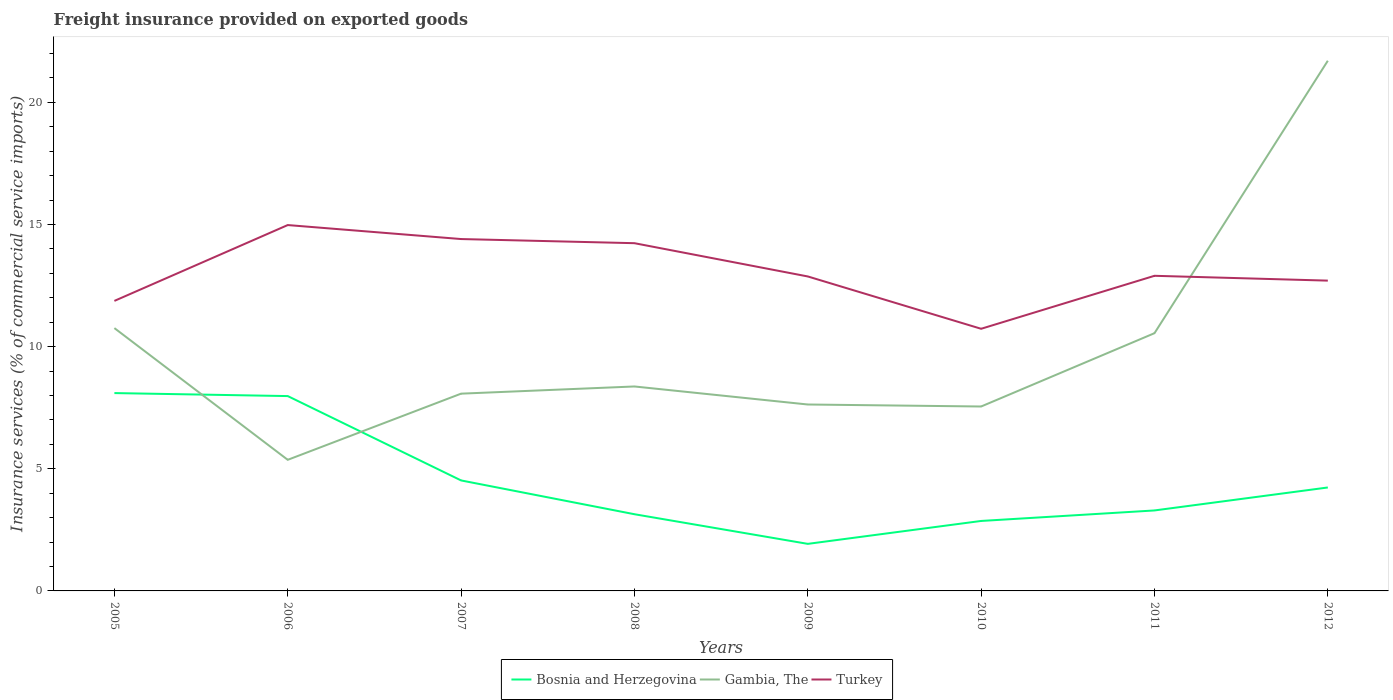How many different coloured lines are there?
Offer a very short reply. 3. Across all years, what is the maximum freight insurance provided on exported goods in Gambia, The?
Your answer should be compact. 5.37. What is the total freight insurance provided on exported goods in Bosnia and Herzegovina in the graph?
Ensure brevity in your answer.  1.66. What is the difference between the highest and the second highest freight insurance provided on exported goods in Gambia, The?
Ensure brevity in your answer.  16.34. Is the freight insurance provided on exported goods in Bosnia and Herzegovina strictly greater than the freight insurance provided on exported goods in Turkey over the years?
Ensure brevity in your answer.  Yes. How many lines are there?
Offer a terse response. 3. How many years are there in the graph?
Provide a succinct answer. 8. What is the difference between two consecutive major ticks on the Y-axis?
Ensure brevity in your answer.  5. Does the graph contain grids?
Your answer should be compact. No. Where does the legend appear in the graph?
Your answer should be very brief. Bottom center. How many legend labels are there?
Give a very brief answer. 3. What is the title of the graph?
Ensure brevity in your answer.  Freight insurance provided on exported goods. Does "Least developed countries" appear as one of the legend labels in the graph?
Give a very brief answer. No. What is the label or title of the Y-axis?
Give a very brief answer. Insurance services (% of commercial service imports). What is the Insurance services (% of commercial service imports) in Bosnia and Herzegovina in 2005?
Your response must be concise. 8.1. What is the Insurance services (% of commercial service imports) in Gambia, The in 2005?
Keep it short and to the point. 10.76. What is the Insurance services (% of commercial service imports) in Turkey in 2005?
Offer a terse response. 11.87. What is the Insurance services (% of commercial service imports) in Bosnia and Herzegovina in 2006?
Make the answer very short. 7.98. What is the Insurance services (% of commercial service imports) in Gambia, The in 2006?
Your answer should be very brief. 5.37. What is the Insurance services (% of commercial service imports) of Turkey in 2006?
Keep it short and to the point. 14.98. What is the Insurance services (% of commercial service imports) in Bosnia and Herzegovina in 2007?
Offer a terse response. 4.52. What is the Insurance services (% of commercial service imports) in Gambia, The in 2007?
Keep it short and to the point. 8.08. What is the Insurance services (% of commercial service imports) of Turkey in 2007?
Keep it short and to the point. 14.4. What is the Insurance services (% of commercial service imports) of Bosnia and Herzegovina in 2008?
Provide a short and direct response. 3.14. What is the Insurance services (% of commercial service imports) in Gambia, The in 2008?
Offer a very short reply. 8.37. What is the Insurance services (% of commercial service imports) in Turkey in 2008?
Offer a very short reply. 14.23. What is the Insurance services (% of commercial service imports) in Bosnia and Herzegovina in 2009?
Your answer should be compact. 1.93. What is the Insurance services (% of commercial service imports) in Gambia, The in 2009?
Offer a very short reply. 7.63. What is the Insurance services (% of commercial service imports) in Turkey in 2009?
Your answer should be compact. 12.87. What is the Insurance services (% of commercial service imports) in Bosnia and Herzegovina in 2010?
Your response must be concise. 2.86. What is the Insurance services (% of commercial service imports) in Gambia, The in 2010?
Your answer should be very brief. 7.55. What is the Insurance services (% of commercial service imports) in Turkey in 2010?
Your answer should be very brief. 10.73. What is the Insurance services (% of commercial service imports) of Bosnia and Herzegovina in 2011?
Your answer should be compact. 3.29. What is the Insurance services (% of commercial service imports) in Gambia, The in 2011?
Offer a very short reply. 10.55. What is the Insurance services (% of commercial service imports) of Turkey in 2011?
Your answer should be compact. 12.9. What is the Insurance services (% of commercial service imports) in Bosnia and Herzegovina in 2012?
Keep it short and to the point. 4.23. What is the Insurance services (% of commercial service imports) in Gambia, The in 2012?
Give a very brief answer. 21.7. What is the Insurance services (% of commercial service imports) of Turkey in 2012?
Give a very brief answer. 12.7. Across all years, what is the maximum Insurance services (% of commercial service imports) of Bosnia and Herzegovina?
Give a very brief answer. 8.1. Across all years, what is the maximum Insurance services (% of commercial service imports) of Gambia, The?
Provide a succinct answer. 21.7. Across all years, what is the maximum Insurance services (% of commercial service imports) of Turkey?
Offer a very short reply. 14.98. Across all years, what is the minimum Insurance services (% of commercial service imports) in Bosnia and Herzegovina?
Provide a short and direct response. 1.93. Across all years, what is the minimum Insurance services (% of commercial service imports) of Gambia, The?
Ensure brevity in your answer.  5.37. Across all years, what is the minimum Insurance services (% of commercial service imports) of Turkey?
Offer a terse response. 10.73. What is the total Insurance services (% of commercial service imports) of Bosnia and Herzegovina in the graph?
Offer a terse response. 36.06. What is the total Insurance services (% of commercial service imports) in Gambia, The in the graph?
Offer a very short reply. 80.01. What is the total Insurance services (% of commercial service imports) in Turkey in the graph?
Keep it short and to the point. 104.69. What is the difference between the Insurance services (% of commercial service imports) in Bosnia and Herzegovina in 2005 and that in 2006?
Your answer should be very brief. 0.12. What is the difference between the Insurance services (% of commercial service imports) in Gambia, The in 2005 and that in 2006?
Give a very brief answer. 5.39. What is the difference between the Insurance services (% of commercial service imports) of Turkey in 2005 and that in 2006?
Your answer should be compact. -3.1. What is the difference between the Insurance services (% of commercial service imports) in Bosnia and Herzegovina in 2005 and that in 2007?
Provide a succinct answer. 3.58. What is the difference between the Insurance services (% of commercial service imports) in Gambia, The in 2005 and that in 2007?
Ensure brevity in your answer.  2.68. What is the difference between the Insurance services (% of commercial service imports) of Turkey in 2005 and that in 2007?
Make the answer very short. -2.53. What is the difference between the Insurance services (% of commercial service imports) of Bosnia and Herzegovina in 2005 and that in 2008?
Give a very brief answer. 4.96. What is the difference between the Insurance services (% of commercial service imports) of Gambia, The in 2005 and that in 2008?
Provide a short and direct response. 2.39. What is the difference between the Insurance services (% of commercial service imports) in Turkey in 2005 and that in 2008?
Give a very brief answer. -2.36. What is the difference between the Insurance services (% of commercial service imports) in Bosnia and Herzegovina in 2005 and that in 2009?
Give a very brief answer. 6.17. What is the difference between the Insurance services (% of commercial service imports) of Gambia, The in 2005 and that in 2009?
Your response must be concise. 3.13. What is the difference between the Insurance services (% of commercial service imports) of Turkey in 2005 and that in 2009?
Offer a terse response. -1. What is the difference between the Insurance services (% of commercial service imports) in Bosnia and Herzegovina in 2005 and that in 2010?
Make the answer very short. 5.23. What is the difference between the Insurance services (% of commercial service imports) in Gambia, The in 2005 and that in 2010?
Offer a terse response. 3.21. What is the difference between the Insurance services (% of commercial service imports) of Turkey in 2005 and that in 2010?
Your answer should be compact. 1.14. What is the difference between the Insurance services (% of commercial service imports) in Bosnia and Herzegovina in 2005 and that in 2011?
Keep it short and to the point. 4.8. What is the difference between the Insurance services (% of commercial service imports) of Gambia, The in 2005 and that in 2011?
Your answer should be very brief. 0.21. What is the difference between the Insurance services (% of commercial service imports) in Turkey in 2005 and that in 2011?
Ensure brevity in your answer.  -1.03. What is the difference between the Insurance services (% of commercial service imports) of Bosnia and Herzegovina in 2005 and that in 2012?
Make the answer very short. 3.86. What is the difference between the Insurance services (% of commercial service imports) of Gambia, The in 2005 and that in 2012?
Keep it short and to the point. -10.94. What is the difference between the Insurance services (% of commercial service imports) in Turkey in 2005 and that in 2012?
Provide a succinct answer. -0.83. What is the difference between the Insurance services (% of commercial service imports) in Bosnia and Herzegovina in 2006 and that in 2007?
Make the answer very short. 3.45. What is the difference between the Insurance services (% of commercial service imports) of Gambia, The in 2006 and that in 2007?
Your answer should be compact. -2.71. What is the difference between the Insurance services (% of commercial service imports) of Turkey in 2006 and that in 2007?
Your answer should be very brief. 0.57. What is the difference between the Insurance services (% of commercial service imports) in Bosnia and Herzegovina in 2006 and that in 2008?
Give a very brief answer. 4.84. What is the difference between the Insurance services (% of commercial service imports) in Gambia, The in 2006 and that in 2008?
Your answer should be very brief. -3. What is the difference between the Insurance services (% of commercial service imports) of Turkey in 2006 and that in 2008?
Provide a succinct answer. 0.74. What is the difference between the Insurance services (% of commercial service imports) of Bosnia and Herzegovina in 2006 and that in 2009?
Provide a short and direct response. 6.05. What is the difference between the Insurance services (% of commercial service imports) in Gambia, The in 2006 and that in 2009?
Keep it short and to the point. -2.26. What is the difference between the Insurance services (% of commercial service imports) of Turkey in 2006 and that in 2009?
Provide a succinct answer. 2.1. What is the difference between the Insurance services (% of commercial service imports) in Bosnia and Herzegovina in 2006 and that in 2010?
Ensure brevity in your answer.  5.11. What is the difference between the Insurance services (% of commercial service imports) in Gambia, The in 2006 and that in 2010?
Provide a short and direct response. -2.18. What is the difference between the Insurance services (% of commercial service imports) in Turkey in 2006 and that in 2010?
Your response must be concise. 4.25. What is the difference between the Insurance services (% of commercial service imports) in Bosnia and Herzegovina in 2006 and that in 2011?
Offer a terse response. 4.68. What is the difference between the Insurance services (% of commercial service imports) of Gambia, The in 2006 and that in 2011?
Ensure brevity in your answer.  -5.18. What is the difference between the Insurance services (% of commercial service imports) in Turkey in 2006 and that in 2011?
Give a very brief answer. 2.08. What is the difference between the Insurance services (% of commercial service imports) in Bosnia and Herzegovina in 2006 and that in 2012?
Offer a very short reply. 3.74. What is the difference between the Insurance services (% of commercial service imports) of Gambia, The in 2006 and that in 2012?
Ensure brevity in your answer.  -16.34. What is the difference between the Insurance services (% of commercial service imports) in Turkey in 2006 and that in 2012?
Your answer should be very brief. 2.27. What is the difference between the Insurance services (% of commercial service imports) in Bosnia and Herzegovina in 2007 and that in 2008?
Your answer should be very brief. 1.38. What is the difference between the Insurance services (% of commercial service imports) of Gambia, The in 2007 and that in 2008?
Your answer should be very brief. -0.29. What is the difference between the Insurance services (% of commercial service imports) in Turkey in 2007 and that in 2008?
Your answer should be very brief. 0.17. What is the difference between the Insurance services (% of commercial service imports) of Bosnia and Herzegovina in 2007 and that in 2009?
Ensure brevity in your answer.  2.6. What is the difference between the Insurance services (% of commercial service imports) in Gambia, The in 2007 and that in 2009?
Your response must be concise. 0.44. What is the difference between the Insurance services (% of commercial service imports) in Turkey in 2007 and that in 2009?
Provide a succinct answer. 1.53. What is the difference between the Insurance services (% of commercial service imports) of Bosnia and Herzegovina in 2007 and that in 2010?
Your answer should be very brief. 1.66. What is the difference between the Insurance services (% of commercial service imports) of Gambia, The in 2007 and that in 2010?
Give a very brief answer. 0.53. What is the difference between the Insurance services (% of commercial service imports) of Turkey in 2007 and that in 2010?
Give a very brief answer. 3.67. What is the difference between the Insurance services (% of commercial service imports) in Bosnia and Herzegovina in 2007 and that in 2011?
Provide a short and direct response. 1.23. What is the difference between the Insurance services (% of commercial service imports) of Gambia, The in 2007 and that in 2011?
Keep it short and to the point. -2.48. What is the difference between the Insurance services (% of commercial service imports) in Turkey in 2007 and that in 2011?
Offer a terse response. 1.5. What is the difference between the Insurance services (% of commercial service imports) in Bosnia and Herzegovina in 2007 and that in 2012?
Your response must be concise. 0.29. What is the difference between the Insurance services (% of commercial service imports) of Gambia, The in 2007 and that in 2012?
Your answer should be compact. -13.63. What is the difference between the Insurance services (% of commercial service imports) in Turkey in 2007 and that in 2012?
Ensure brevity in your answer.  1.7. What is the difference between the Insurance services (% of commercial service imports) of Bosnia and Herzegovina in 2008 and that in 2009?
Provide a succinct answer. 1.21. What is the difference between the Insurance services (% of commercial service imports) of Gambia, The in 2008 and that in 2009?
Offer a terse response. 0.74. What is the difference between the Insurance services (% of commercial service imports) of Turkey in 2008 and that in 2009?
Ensure brevity in your answer.  1.36. What is the difference between the Insurance services (% of commercial service imports) of Bosnia and Herzegovina in 2008 and that in 2010?
Ensure brevity in your answer.  0.28. What is the difference between the Insurance services (% of commercial service imports) in Gambia, The in 2008 and that in 2010?
Ensure brevity in your answer.  0.82. What is the difference between the Insurance services (% of commercial service imports) in Turkey in 2008 and that in 2010?
Offer a very short reply. 3.5. What is the difference between the Insurance services (% of commercial service imports) in Bosnia and Herzegovina in 2008 and that in 2011?
Give a very brief answer. -0.15. What is the difference between the Insurance services (% of commercial service imports) in Gambia, The in 2008 and that in 2011?
Offer a terse response. -2.18. What is the difference between the Insurance services (% of commercial service imports) of Turkey in 2008 and that in 2011?
Provide a succinct answer. 1.33. What is the difference between the Insurance services (% of commercial service imports) in Bosnia and Herzegovina in 2008 and that in 2012?
Provide a succinct answer. -1.09. What is the difference between the Insurance services (% of commercial service imports) in Gambia, The in 2008 and that in 2012?
Offer a terse response. -13.33. What is the difference between the Insurance services (% of commercial service imports) in Turkey in 2008 and that in 2012?
Keep it short and to the point. 1.53. What is the difference between the Insurance services (% of commercial service imports) of Bosnia and Herzegovina in 2009 and that in 2010?
Your response must be concise. -0.94. What is the difference between the Insurance services (% of commercial service imports) of Gambia, The in 2009 and that in 2010?
Provide a succinct answer. 0.08. What is the difference between the Insurance services (% of commercial service imports) in Turkey in 2009 and that in 2010?
Keep it short and to the point. 2.14. What is the difference between the Insurance services (% of commercial service imports) in Bosnia and Herzegovina in 2009 and that in 2011?
Make the answer very short. -1.37. What is the difference between the Insurance services (% of commercial service imports) of Gambia, The in 2009 and that in 2011?
Your answer should be compact. -2.92. What is the difference between the Insurance services (% of commercial service imports) in Turkey in 2009 and that in 2011?
Provide a short and direct response. -0.03. What is the difference between the Insurance services (% of commercial service imports) in Bosnia and Herzegovina in 2009 and that in 2012?
Provide a short and direct response. -2.31. What is the difference between the Insurance services (% of commercial service imports) in Gambia, The in 2009 and that in 2012?
Keep it short and to the point. -14.07. What is the difference between the Insurance services (% of commercial service imports) in Turkey in 2009 and that in 2012?
Your response must be concise. 0.17. What is the difference between the Insurance services (% of commercial service imports) of Bosnia and Herzegovina in 2010 and that in 2011?
Your response must be concise. -0.43. What is the difference between the Insurance services (% of commercial service imports) in Gambia, The in 2010 and that in 2011?
Give a very brief answer. -3. What is the difference between the Insurance services (% of commercial service imports) of Turkey in 2010 and that in 2011?
Give a very brief answer. -2.17. What is the difference between the Insurance services (% of commercial service imports) in Bosnia and Herzegovina in 2010 and that in 2012?
Ensure brevity in your answer.  -1.37. What is the difference between the Insurance services (% of commercial service imports) of Gambia, The in 2010 and that in 2012?
Offer a terse response. -14.15. What is the difference between the Insurance services (% of commercial service imports) of Turkey in 2010 and that in 2012?
Your response must be concise. -1.97. What is the difference between the Insurance services (% of commercial service imports) of Bosnia and Herzegovina in 2011 and that in 2012?
Make the answer very short. -0.94. What is the difference between the Insurance services (% of commercial service imports) of Gambia, The in 2011 and that in 2012?
Make the answer very short. -11.15. What is the difference between the Insurance services (% of commercial service imports) of Turkey in 2011 and that in 2012?
Make the answer very short. 0.2. What is the difference between the Insurance services (% of commercial service imports) in Bosnia and Herzegovina in 2005 and the Insurance services (% of commercial service imports) in Gambia, The in 2006?
Ensure brevity in your answer.  2.73. What is the difference between the Insurance services (% of commercial service imports) of Bosnia and Herzegovina in 2005 and the Insurance services (% of commercial service imports) of Turkey in 2006?
Ensure brevity in your answer.  -6.88. What is the difference between the Insurance services (% of commercial service imports) of Gambia, The in 2005 and the Insurance services (% of commercial service imports) of Turkey in 2006?
Ensure brevity in your answer.  -4.22. What is the difference between the Insurance services (% of commercial service imports) of Bosnia and Herzegovina in 2005 and the Insurance services (% of commercial service imports) of Gambia, The in 2007?
Offer a terse response. 0.02. What is the difference between the Insurance services (% of commercial service imports) in Bosnia and Herzegovina in 2005 and the Insurance services (% of commercial service imports) in Turkey in 2007?
Provide a short and direct response. -6.31. What is the difference between the Insurance services (% of commercial service imports) in Gambia, The in 2005 and the Insurance services (% of commercial service imports) in Turkey in 2007?
Offer a terse response. -3.65. What is the difference between the Insurance services (% of commercial service imports) of Bosnia and Herzegovina in 2005 and the Insurance services (% of commercial service imports) of Gambia, The in 2008?
Provide a short and direct response. -0.27. What is the difference between the Insurance services (% of commercial service imports) of Bosnia and Herzegovina in 2005 and the Insurance services (% of commercial service imports) of Turkey in 2008?
Offer a terse response. -6.14. What is the difference between the Insurance services (% of commercial service imports) in Gambia, The in 2005 and the Insurance services (% of commercial service imports) in Turkey in 2008?
Make the answer very short. -3.48. What is the difference between the Insurance services (% of commercial service imports) in Bosnia and Herzegovina in 2005 and the Insurance services (% of commercial service imports) in Gambia, The in 2009?
Provide a short and direct response. 0.47. What is the difference between the Insurance services (% of commercial service imports) in Bosnia and Herzegovina in 2005 and the Insurance services (% of commercial service imports) in Turkey in 2009?
Give a very brief answer. -4.77. What is the difference between the Insurance services (% of commercial service imports) in Gambia, The in 2005 and the Insurance services (% of commercial service imports) in Turkey in 2009?
Offer a terse response. -2.11. What is the difference between the Insurance services (% of commercial service imports) of Bosnia and Herzegovina in 2005 and the Insurance services (% of commercial service imports) of Gambia, The in 2010?
Make the answer very short. 0.55. What is the difference between the Insurance services (% of commercial service imports) of Bosnia and Herzegovina in 2005 and the Insurance services (% of commercial service imports) of Turkey in 2010?
Make the answer very short. -2.63. What is the difference between the Insurance services (% of commercial service imports) of Gambia, The in 2005 and the Insurance services (% of commercial service imports) of Turkey in 2010?
Keep it short and to the point. 0.03. What is the difference between the Insurance services (% of commercial service imports) in Bosnia and Herzegovina in 2005 and the Insurance services (% of commercial service imports) in Gambia, The in 2011?
Ensure brevity in your answer.  -2.45. What is the difference between the Insurance services (% of commercial service imports) of Bosnia and Herzegovina in 2005 and the Insurance services (% of commercial service imports) of Turkey in 2011?
Provide a succinct answer. -4.8. What is the difference between the Insurance services (% of commercial service imports) of Gambia, The in 2005 and the Insurance services (% of commercial service imports) of Turkey in 2011?
Offer a terse response. -2.14. What is the difference between the Insurance services (% of commercial service imports) in Bosnia and Herzegovina in 2005 and the Insurance services (% of commercial service imports) in Gambia, The in 2012?
Give a very brief answer. -13.61. What is the difference between the Insurance services (% of commercial service imports) in Bosnia and Herzegovina in 2005 and the Insurance services (% of commercial service imports) in Turkey in 2012?
Offer a very short reply. -4.6. What is the difference between the Insurance services (% of commercial service imports) of Gambia, The in 2005 and the Insurance services (% of commercial service imports) of Turkey in 2012?
Keep it short and to the point. -1.94. What is the difference between the Insurance services (% of commercial service imports) of Bosnia and Herzegovina in 2006 and the Insurance services (% of commercial service imports) of Gambia, The in 2007?
Provide a succinct answer. -0.1. What is the difference between the Insurance services (% of commercial service imports) in Bosnia and Herzegovina in 2006 and the Insurance services (% of commercial service imports) in Turkey in 2007?
Offer a very short reply. -6.43. What is the difference between the Insurance services (% of commercial service imports) in Gambia, The in 2006 and the Insurance services (% of commercial service imports) in Turkey in 2007?
Give a very brief answer. -9.04. What is the difference between the Insurance services (% of commercial service imports) of Bosnia and Herzegovina in 2006 and the Insurance services (% of commercial service imports) of Gambia, The in 2008?
Your answer should be very brief. -0.39. What is the difference between the Insurance services (% of commercial service imports) in Bosnia and Herzegovina in 2006 and the Insurance services (% of commercial service imports) in Turkey in 2008?
Offer a very short reply. -6.26. What is the difference between the Insurance services (% of commercial service imports) of Gambia, The in 2006 and the Insurance services (% of commercial service imports) of Turkey in 2008?
Keep it short and to the point. -8.87. What is the difference between the Insurance services (% of commercial service imports) of Bosnia and Herzegovina in 2006 and the Insurance services (% of commercial service imports) of Gambia, The in 2009?
Provide a short and direct response. 0.34. What is the difference between the Insurance services (% of commercial service imports) of Bosnia and Herzegovina in 2006 and the Insurance services (% of commercial service imports) of Turkey in 2009?
Your response must be concise. -4.9. What is the difference between the Insurance services (% of commercial service imports) in Gambia, The in 2006 and the Insurance services (% of commercial service imports) in Turkey in 2009?
Offer a terse response. -7.51. What is the difference between the Insurance services (% of commercial service imports) of Bosnia and Herzegovina in 2006 and the Insurance services (% of commercial service imports) of Gambia, The in 2010?
Give a very brief answer. 0.43. What is the difference between the Insurance services (% of commercial service imports) of Bosnia and Herzegovina in 2006 and the Insurance services (% of commercial service imports) of Turkey in 2010?
Offer a terse response. -2.75. What is the difference between the Insurance services (% of commercial service imports) in Gambia, The in 2006 and the Insurance services (% of commercial service imports) in Turkey in 2010?
Keep it short and to the point. -5.36. What is the difference between the Insurance services (% of commercial service imports) of Bosnia and Herzegovina in 2006 and the Insurance services (% of commercial service imports) of Gambia, The in 2011?
Offer a very short reply. -2.57. What is the difference between the Insurance services (% of commercial service imports) of Bosnia and Herzegovina in 2006 and the Insurance services (% of commercial service imports) of Turkey in 2011?
Your answer should be very brief. -4.92. What is the difference between the Insurance services (% of commercial service imports) in Gambia, The in 2006 and the Insurance services (% of commercial service imports) in Turkey in 2011?
Provide a succinct answer. -7.53. What is the difference between the Insurance services (% of commercial service imports) of Bosnia and Herzegovina in 2006 and the Insurance services (% of commercial service imports) of Gambia, The in 2012?
Provide a short and direct response. -13.73. What is the difference between the Insurance services (% of commercial service imports) in Bosnia and Herzegovina in 2006 and the Insurance services (% of commercial service imports) in Turkey in 2012?
Make the answer very short. -4.73. What is the difference between the Insurance services (% of commercial service imports) of Gambia, The in 2006 and the Insurance services (% of commercial service imports) of Turkey in 2012?
Your response must be concise. -7.34. What is the difference between the Insurance services (% of commercial service imports) of Bosnia and Herzegovina in 2007 and the Insurance services (% of commercial service imports) of Gambia, The in 2008?
Ensure brevity in your answer.  -3.85. What is the difference between the Insurance services (% of commercial service imports) of Bosnia and Herzegovina in 2007 and the Insurance services (% of commercial service imports) of Turkey in 2008?
Make the answer very short. -9.71. What is the difference between the Insurance services (% of commercial service imports) in Gambia, The in 2007 and the Insurance services (% of commercial service imports) in Turkey in 2008?
Provide a short and direct response. -6.16. What is the difference between the Insurance services (% of commercial service imports) in Bosnia and Herzegovina in 2007 and the Insurance services (% of commercial service imports) in Gambia, The in 2009?
Keep it short and to the point. -3.11. What is the difference between the Insurance services (% of commercial service imports) of Bosnia and Herzegovina in 2007 and the Insurance services (% of commercial service imports) of Turkey in 2009?
Your response must be concise. -8.35. What is the difference between the Insurance services (% of commercial service imports) in Gambia, The in 2007 and the Insurance services (% of commercial service imports) in Turkey in 2009?
Ensure brevity in your answer.  -4.8. What is the difference between the Insurance services (% of commercial service imports) of Bosnia and Herzegovina in 2007 and the Insurance services (% of commercial service imports) of Gambia, The in 2010?
Keep it short and to the point. -3.03. What is the difference between the Insurance services (% of commercial service imports) in Bosnia and Herzegovina in 2007 and the Insurance services (% of commercial service imports) in Turkey in 2010?
Your answer should be compact. -6.21. What is the difference between the Insurance services (% of commercial service imports) in Gambia, The in 2007 and the Insurance services (% of commercial service imports) in Turkey in 2010?
Provide a succinct answer. -2.66. What is the difference between the Insurance services (% of commercial service imports) in Bosnia and Herzegovina in 2007 and the Insurance services (% of commercial service imports) in Gambia, The in 2011?
Your answer should be compact. -6.03. What is the difference between the Insurance services (% of commercial service imports) of Bosnia and Herzegovina in 2007 and the Insurance services (% of commercial service imports) of Turkey in 2011?
Your answer should be very brief. -8.38. What is the difference between the Insurance services (% of commercial service imports) of Gambia, The in 2007 and the Insurance services (% of commercial service imports) of Turkey in 2011?
Give a very brief answer. -4.82. What is the difference between the Insurance services (% of commercial service imports) in Bosnia and Herzegovina in 2007 and the Insurance services (% of commercial service imports) in Gambia, The in 2012?
Give a very brief answer. -17.18. What is the difference between the Insurance services (% of commercial service imports) in Bosnia and Herzegovina in 2007 and the Insurance services (% of commercial service imports) in Turkey in 2012?
Your answer should be very brief. -8.18. What is the difference between the Insurance services (% of commercial service imports) in Gambia, The in 2007 and the Insurance services (% of commercial service imports) in Turkey in 2012?
Offer a terse response. -4.63. What is the difference between the Insurance services (% of commercial service imports) of Bosnia and Herzegovina in 2008 and the Insurance services (% of commercial service imports) of Gambia, The in 2009?
Your answer should be very brief. -4.49. What is the difference between the Insurance services (% of commercial service imports) in Bosnia and Herzegovina in 2008 and the Insurance services (% of commercial service imports) in Turkey in 2009?
Your answer should be very brief. -9.73. What is the difference between the Insurance services (% of commercial service imports) in Gambia, The in 2008 and the Insurance services (% of commercial service imports) in Turkey in 2009?
Provide a short and direct response. -4.5. What is the difference between the Insurance services (% of commercial service imports) in Bosnia and Herzegovina in 2008 and the Insurance services (% of commercial service imports) in Gambia, The in 2010?
Provide a short and direct response. -4.41. What is the difference between the Insurance services (% of commercial service imports) in Bosnia and Herzegovina in 2008 and the Insurance services (% of commercial service imports) in Turkey in 2010?
Make the answer very short. -7.59. What is the difference between the Insurance services (% of commercial service imports) of Gambia, The in 2008 and the Insurance services (% of commercial service imports) of Turkey in 2010?
Make the answer very short. -2.36. What is the difference between the Insurance services (% of commercial service imports) in Bosnia and Herzegovina in 2008 and the Insurance services (% of commercial service imports) in Gambia, The in 2011?
Your response must be concise. -7.41. What is the difference between the Insurance services (% of commercial service imports) of Bosnia and Herzegovina in 2008 and the Insurance services (% of commercial service imports) of Turkey in 2011?
Provide a short and direct response. -9.76. What is the difference between the Insurance services (% of commercial service imports) of Gambia, The in 2008 and the Insurance services (% of commercial service imports) of Turkey in 2011?
Provide a short and direct response. -4.53. What is the difference between the Insurance services (% of commercial service imports) in Bosnia and Herzegovina in 2008 and the Insurance services (% of commercial service imports) in Gambia, The in 2012?
Ensure brevity in your answer.  -18.56. What is the difference between the Insurance services (% of commercial service imports) in Bosnia and Herzegovina in 2008 and the Insurance services (% of commercial service imports) in Turkey in 2012?
Make the answer very short. -9.56. What is the difference between the Insurance services (% of commercial service imports) of Gambia, The in 2008 and the Insurance services (% of commercial service imports) of Turkey in 2012?
Keep it short and to the point. -4.33. What is the difference between the Insurance services (% of commercial service imports) of Bosnia and Herzegovina in 2009 and the Insurance services (% of commercial service imports) of Gambia, The in 2010?
Your answer should be very brief. -5.62. What is the difference between the Insurance services (% of commercial service imports) of Bosnia and Herzegovina in 2009 and the Insurance services (% of commercial service imports) of Turkey in 2010?
Give a very brief answer. -8.8. What is the difference between the Insurance services (% of commercial service imports) in Gambia, The in 2009 and the Insurance services (% of commercial service imports) in Turkey in 2010?
Ensure brevity in your answer.  -3.1. What is the difference between the Insurance services (% of commercial service imports) in Bosnia and Herzegovina in 2009 and the Insurance services (% of commercial service imports) in Gambia, The in 2011?
Offer a very short reply. -8.62. What is the difference between the Insurance services (% of commercial service imports) in Bosnia and Herzegovina in 2009 and the Insurance services (% of commercial service imports) in Turkey in 2011?
Your answer should be compact. -10.97. What is the difference between the Insurance services (% of commercial service imports) of Gambia, The in 2009 and the Insurance services (% of commercial service imports) of Turkey in 2011?
Offer a terse response. -5.27. What is the difference between the Insurance services (% of commercial service imports) of Bosnia and Herzegovina in 2009 and the Insurance services (% of commercial service imports) of Gambia, The in 2012?
Provide a succinct answer. -19.78. What is the difference between the Insurance services (% of commercial service imports) in Bosnia and Herzegovina in 2009 and the Insurance services (% of commercial service imports) in Turkey in 2012?
Give a very brief answer. -10.78. What is the difference between the Insurance services (% of commercial service imports) of Gambia, The in 2009 and the Insurance services (% of commercial service imports) of Turkey in 2012?
Provide a succinct answer. -5.07. What is the difference between the Insurance services (% of commercial service imports) of Bosnia and Herzegovina in 2010 and the Insurance services (% of commercial service imports) of Gambia, The in 2011?
Make the answer very short. -7.69. What is the difference between the Insurance services (% of commercial service imports) in Bosnia and Herzegovina in 2010 and the Insurance services (% of commercial service imports) in Turkey in 2011?
Offer a terse response. -10.04. What is the difference between the Insurance services (% of commercial service imports) in Gambia, The in 2010 and the Insurance services (% of commercial service imports) in Turkey in 2011?
Provide a short and direct response. -5.35. What is the difference between the Insurance services (% of commercial service imports) of Bosnia and Herzegovina in 2010 and the Insurance services (% of commercial service imports) of Gambia, The in 2012?
Make the answer very short. -18.84. What is the difference between the Insurance services (% of commercial service imports) of Bosnia and Herzegovina in 2010 and the Insurance services (% of commercial service imports) of Turkey in 2012?
Your response must be concise. -9.84. What is the difference between the Insurance services (% of commercial service imports) in Gambia, The in 2010 and the Insurance services (% of commercial service imports) in Turkey in 2012?
Ensure brevity in your answer.  -5.15. What is the difference between the Insurance services (% of commercial service imports) in Bosnia and Herzegovina in 2011 and the Insurance services (% of commercial service imports) in Gambia, The in 2012?
Make the answer very short. -18.41. What is the difference between the Insurance services (% of commercial service imports) of Bosnia and Herzegovina in 2011 and the Insurance services (% of commercial service imports) of Turkey in 2012?
Ensure brevity in your answer.  -9.41. What is the difference between the Insurance services (% of commercial service imports) in Gambia, The in 2011 and the Insurance services (% of commercial service imports) in Turkey in 2012?
Provide a succinct answer. -2.15. What is the average Insurance services (% of commercial service imports) of Bosnia and Herzegovina per year?
Your answer should be compact. 4.51. What is the average Insurance services (% of commercial service imports) of Gambia, The per year?
Your answer should be very brief. 10. What is the average Insurance services (% of commercial service imports) of Turkey per year?
Your answer should be compact. 13.09. In the year 2005, what is the difference between the Insurance services (% of commercial service imports) of Bosnia and Herzegovina and Insurance services (% of commercial service imports) of Gambia, The?
Keep it short and to the point. -2.66. In the year 2005, what is the difference between the Insurance services (% of commercial service imports) of Bosnia and Herzegovina and Insurance services (% of commercial service imports) of Turkey?
Offer a very short reply. -3.77. In the year 2005, what is the difference between the Insurance services (% of commercial service imports) of Gambia, The and Insurance services (% of commercial service imports) of Turkey?
Your answer should be compact. -1.11. In the year 2006, what is the difference between the Insurance services (% of commercial service imports) in Bosnia and Herzegovina and Insurance services (% of commercial service imports) in Gambia, The?
Your answer should be compact. 2.61. In the year 2006, what is the difference between the Insurance services (% of commercial service imports) in Bosnia and Herzegovina and Insurance services (% of commercial service imports) in Turkey?
Your response must be concise. -7. In the year 2006, what is the difference between the Insurance services (% of commercial service imports) of Gambia, The and Insurance services (% of commercial service imports) of Turkey?
Your answer should be very brief. -9.61. In the year 2007, what is the difference between the Insurance services (% of commercial service imports) in Bosnia and Herzegovina and Insurance services (% of commercial service imports) in Gambia, The?
Offer a terse response. -3.55. In the year 2007, what is the difference between the Insurance services (% of commercial service imports) of Bosnia and Herzegovina and Insurance services (% of commercial service imports) of Turkey?
Make the answer very short. -9.88. In the year 2007, what is the difference between the Insurance services (% of commercial service imports) of Gambia, The and Insurance services (% of commercial service imports) of Turkey?
Provide a short and direct response. -6.33. In the year 2008, what is the difference between the Insurance services (% of commercial service imports) of Bosnia and Herzegovina and Insurance services (% of commercial service imports) of Gambia, The?
Keep it short and to the point. -5.23. In the year 2008, what is the difference between the Insurance services (% of commercial service imports) in Bosnia and Herzegovina and Insurance services (% of commercial service imports) in Turkey?
Ensure brevity in your answer.  -11.09. In the year 2008, what is the difference between the Insurance services (% of commercial service imports) in Gambia, The and Insurance services (% of commercial service imports) in Turkey?
Offer a terse response. -5.87. In the year 2009, what is the difference between the Insurance services (% of commercial service imports) in Bosnia and Herzegovina and Insurance services (% of commercial service imports) in Gambia, The?
Provide a short and direct response. -5.71. In the year 2009, what is the difference between the Insurance services (% of commercial service imports) of Bosnia and Herzegovina and Insurance services (% of commercial service imports) of Turkey?
Give a very brief answer. -10.95. In the year 2009, what is the difference between the Insurance services (% of commercial service imports) of Gambia, The and Insurance services (% of commercial service imports) of Turkey?
Your answer should be very brief. -5.24. In the year 2010, what is the difference between the Insurance services (% of commercial service imports) of Bosnia and Herzegovina and Insurance services (% of commercial service imports) of Gambia, The?
Your answer should be very brief. -4.69. In the year 2010, what is the difference between the Insurance services (% of commercial service imports) of Bosnia and Herzegovina and Insurance services (% of commercial service imports) of Turkey?
Provide a succinct answer. -7.87. In the year 2010, what is the difference between the Insurance services (% of commercial service imports) in Gambia, The and Insurance services (% of commercial service imports) in Turkey?
Make the answer very short. -3.18. In the year 2011, what is the difference between the Insurance services (% of commercial service imports) in Bosnia and Herzegovina and Insurance services (% of commercial service imports) in Gambia, The?
Offer a very short reply. -7.26. In the year 2011, what is the difference between the Insurance services (% of commercial service imports) in Bosnia and Herzegovina and Insurance services (% of commercial service imports) in Turkey?
Keep it short and to the point. -9.61. In the year 2011, what is the difference between the Insurance services (% of commercial service imports) of Gambia, The and Insurance services (% of commercial service imports) of Turkey?
Keep it short and to the point. -2.35. In the year 2012, what is the difference between the Insurance services (% of commercial service imports) of Bosnia and Herzegovina and Insurance services (% of commercial service imports) of Gambia, The?
Your answer should be very brief. -17.47. In the year 2012, what is the difference between the Insurance services (% of commercial service imports) in Bosnia and Herzegovina and Insurance services (% of commercial service imports) in Turkey?
Ensure brevity in your answer.  -8.47. In the year 2012, what is the difference between the Insurance services (% of commercial service imports) of Gambia, The and Insurance services (% of commercial service imports) of Turkey?
Make the answer very short. 9. What is the ratio of the Insurance services (% of commercial service imports) of Bosnia and Herzegovina in 2005 to that in 2006?
Your answer should be very brief. 1.02. What is the ratio of the Insurance services (% of commercial service imports) in Gambia, The in 2005 to that in 2006?
Provide a short and direct response. 2. What is the ratio of the Insurance services (% of commercial service imports) of Turkey in 2005 to that in 2006?
Offer a very short reply. 0.79. What is the ratio of the Insurance services (% of commercial service imports) of Bosnia and Herzegovina in 2005 to that in 2007?
Offer a very short reply. 1.79. What is the ratio of the Insurance services (% of commercial service imports) in Gambia, The in 2005 to that in 2007?
Ensure brevity in your answer.  1.33. What is the ratio of the Insurance services (% of commercial service imports) of Turkey in 2005 to that in 2007?
Offer a very short reply. 0.82. What is the ratio of the Insurance services (% of commercial service imports) in Bosnia and Herzegovina in 2005 to that in 2008?
Make the answer very short. 2.58. What is the ratio of the Insurance services (% of commercial service imports) in Gambia, The in 2005 to that in 2008?
Make the answer very short. 1.29. What is the ratio of the Insurance services (% of commercial service imports) in Turkey in 2005 to that in 2008?
Keep it short and to the point. 0.83. What is the ratio of the Insurance services (% of commercial service imports) of Bosnia and Herzegovina in 2005 to that in 2009?
Your response must be concise. 4.2. What is the ratio of the Insurance services (% of commercial service imports) in Gambia, The in 2005 to that in 2009?
Keep it short and to the point. 1.41. What is the ratio of the Insurance services (% of commercial service imports) of Turkey in 2005 to that in 2009?
Offer a very short reply. 0.92. What is the ratio of the Insurance services (% of commercial service imports) of Bosnia and Herzegovina in 2005 to that in 2010?
Offer a very short reply. 2.83. What is the ratio of the Insurance services (% of commercial service imports) of Gambia, The in 2005 to that in 2010?
Ensure brevity in your answer.  1.43. What is the ratio of the Insurance services (% of commercial service imports) of Turkey in 2005 to that in 2010?
Keep it short and to the point. 1.11. What is the ratio of the Insurance services (% of commercial service imports) in Bosnia and Herzegovina in 2005 to that in 2011?
Your answer should be very brief. 2.46. What is the ratio of the Insurance services (% of commercial service imports) of Gambia, The in 2005 to that in 2011?
Your answer should be compact. 1.02. What is the ratio of the Insurance services (% of commercial service imports) in Turkey in 2005 to that in 2011?
Ensure brevity in your answer.  0.92. What is the ratio of the Insurance services (% of commercial service imports) in Bosnia and Herzegovina in 2005 to that in 2012?
Offer a terse response. 1.91. What is the ratio of the Insurance services (% of commercial service imports) of Gambia, The in 2005 to that in 2012?
Keep it short and to the point. 0.5. What is the ratio of the Insurance services (% of commercial service imports) in Turkey in 2005 to that in 2012?
Your answer should be compact. 0.93. What is the ratio of the Insurance services (% of commercial service imports) of Bosnia and Herzegovina in 2006 to that in 2007?
Your answer should be very brief. 1.76. What is the ratio of the Insurance services (% of commercial service imports) of Gambia, The in 2006 to that in 2007?
Offer a very short reply. 0.66. What is the ratio of the Insurance services (% of commercial service imports) in Turkey in 2006 to that in 2007?
Provide a short and direct response. 1.04. What is the ratio of the Insurance services (% of commercial service imports) in Bosnia and Herzegovina in 2006 to that in 2008?
Give a very brief answer. 2.54. What is the ratio of the Insurance services (% of commercial service imports) of Gambia, The in 2006 to that in 2008?
Ensure brevity in your answer.  0.64. What is the ratio of the Insurance services (% of commercial service imports) in Turkey in 2006 to that in 2008?
Keep it short and to the point. 1.05. What is the ratio of the Insurance services (% of commercial service imports) in Bosnia and Herzegovina in 2006 to that in 2009?
Provide a succinct answer. 4.14. What is the ratio of the Insurance services (% of commercial service imports) in Gambia, The in 2006 to that in 2009?
Your answer should be compact. 0.7. What is the ratio of the Insurance services (% of commercial service imports) of Turkey in 2006 to that in 2009?
Provide a succinct answer. 1.16. What is the ratio of the Insurance services (% of commercial service imports) in Bosnia and Herzegovina in 2006 to that in 2010?
Ensure brevity in your answer.  2.78. What is the ratio of the Insurance services (% of commercial service imports) of Gambia, The in 2006 to that in 2010?
Provide a succinct answer. 0.71. What is the ratio of the Insurance services (% of commercial service imports) in Turkey in 2006 to that in 2010?
Keep it short and to the point. 1.4. What is the ratio of the Insurance services (% of commercial service imports) of Bosnia and Herzegovina in 2006 to that in 2011?
Offer a very short reply. 2.42. What is the ratio of the Insurance services (% of commercial service imports) of Gambia, The in 2006 to that in 2011?
Your response must be concise. 0.51. What is the ratio of the Insurance services (% of commercial service imports) of Turkey in 2006 to that in 2011?
Offer a terse response. 1.16. What is the ratio of the Insurance services (% of commercial service imports) in Bosnia and Herzegovina in 2006 to that in 2012?
Give a very brief answer. 1.88. What is the ratio of the Insurance services (% of commercial service imports) of Gambia, The in 2006 to that in 2012?
Offer a very short reply. 0.25. What is the ratio of the Insurance services (% of commercial service imports) of Turkey in 2006 to that in 2012?
Your answer should be very brief. 1.18. What is the ratio of the Insurance services (% of commercial service imports) in Bosnia and Herzegovina in 2007 to that in 2008?
Offer a very short reply. 1.44. What is the ratio of the Insurance services (% of commercial service imports) in Gambia, The in 2007 to that in 2008?
Provide a short and direct response. 0.96. What is the ratio of the Insurance services (% of commercial service imports) in Turkey in 2007 to that in 2008?
Your answer should be very brief. 1.01. What is the ratio of the Insurance services (% of commercial service imports) in Bosnia and Herzegovina in 2007 to that in 2009?
Ensure brevity in your answer.  2.35. What is the ratio of the Insurance services (% of commercial service imports) in Gambia, The in 2007 to that in 2009?
Ensure brevity in your answer.  1.06. What is the ratio of the Insurance services (% of commercial service imports) of Turkey in 2007 to that in 2009?
Ensure brevity in your answer.  1.12. What is the ratio of the Insurance services (% of commercial service imports) of Bosnia and Herzegovina in 2007 to that in 2010?
Offer a terse response. 1.58. What is the ratio of the Insurance services (% of commercial service imports) of Gambia, The in 2007 to that in 2010?
Your answer should be compact. 1.07. What is the ratio of the Insurance services (% of commercial service imports) in Turkey in 2007 to that in 2010?
Provide a succinct answer. 1.34. What is the ratio of the Insurance services (% of commercial service imports) in Bosnia and Herzegovina in 2007 to that in 2011?
Provide a succinct answer. 1.37. What is the ratio of the Insurance services (% of commercial service imports) in Gambia, The in 2007 to that in 2011?
Ensure brevity in your answer.  0.77. What is the ratio of the Insurance services (% of commercial service imports) of Turkey in 2007 to that in 2011?
Give a very brief answer. 1.12. What is the ratio of the Insurance services (% of commercial service imports) in Bosnia and Herzegovina in 2007 to that in 2012?
Keep it short and to the point. 1.07. What is the ratio of the Insurance services (% of commercial service imports) in Gambia, The in 2007 to that in 2012?
Give a very brief answer. 0.37. What is the ratio of the Insurance services (% of commercial service imports) of Turkey in 2007 to that in 2012?
Your response must be concise. 1.13. What is the ratio of the Insurance services (% of commercial service imports) of Bosnia and Herzegovina in 2008 to that in 2009?
Provide a succinct answer. 1.63. What is the ratio of the Insurance services (% of commercial service imports) in Gambia, The in 2008 to that in 2009?
Provide a short and direct response. 1.1. What is the ratio of the Insurance services (% of commercial service imports) of Turkey in 2008 to that in 2009?
Ensure brevity in your answer.  1.11. What is the ratio of the Insurance services (% of commercial service imports) in Bosnia and Herzegovina in 2008 to that in 2010?
Provide a succinct answer. 1.1. What is the ratio of the Insurance services (% of commercial service imports) in Gambia, The in 2008 to that in 2010?
Keep it short and to the point. 1.11. What is the ratio of the Insurance services (% of commercial service imports) in Turkey in 2008 to that in 2010?
Your answer should be compact. 1.33. What is the ratio of the Insurance services (% of commercial service imports) of Bosnia and Herzegovina in 2008 to that in 2011?
Provide a succinct answer. 0.95. What is the ratio of the Insurance services (% of commercial service imports) in Gambia, The in 2008 to that in 2011?
Make the answer very short. 0.79. What is the ratio of the Insurance services (% of commercial service imports) in Turkey in 2008 to that in 2011?
Provide a short and direct response. 1.1. What is the ratio of the Insurance services (% of commercial service imports) in Bosnia and Herzegovina in 2008 to that in 2012?
Provide a short and direct response. 0.74. What is the ratio of the Insurance services (% of commercial service imports) of Gambia, The in 2008 to that in 2012?
Your answer should be very brief. 0.39. What is the ratio of the Insurance services (% of commercial service imports) of Turkey in 2008 to that in 2012?
Your answer should be compact. 1.12. What is the ratio of the Insurance services (% of commercial service imports) in Bosnia and Herzegovina in 2009 to that in 2010?
Offer a terse response. 0.67. What is the ratio of the Insurance services (% of commercial service imports) in Gambia, The in 2009 to that in 2010?
Provide a succinct answer. 1.01. What is the ratio of the Insurance services (% of commercial service imports) of Turkey in 2009 to that in 2010?
Your response must be concise. 1.2. What is the ratio of the Insurance services (% of commercial service imports) of Bosnia and Herzegovina in 2009 to that in 2011?
Provide a succinct answer. 0.58. What is the ratio of the Insurance services (% of commercial service imports) of Gambia, The in 2009 to that in 2011?
Offer a very short reply. 0.72. What is the ratio of the Insurance services (% of commercial service imports) in Turkey in 2009 to that in 2011?
Offer a very short reply. 1. What is the ratio of the Insurance services (% of commercial service imports) of Bosnia and Herzegovina in 2009 to that in 2012?
Keep it short and to the point. 0.45. What is the ratio of the Insurance services (% of commercial service imports) in Gambia, The in 2009 to that in 2012?
Provide a succinct answer. 0.35. What is the ratio of the Insurance services (% of commercial service imports) in Turkey in 2009 to that in 2012?
Provide a short and direct response. 1.01. What is the ratio of the Insurance services (% of commercial service imports) of Bosnia and Herzegovina in 2010 to that in 2011?
Provide a succinct answer. 0.87. What is the ratio of the Insurance services (% of commercial service imports) in Gambia, The in 2010 to that in 2011?
Your response must be concise. 0.72. What is the ratio of the Insurance services (% of commercial service imports) in Turkey in 2010 to that in 2011?
Provide a short and direct response. 0.83. What is the ratio of the Insurance services (% of commercial service imports) in Bosnia and Herzegovina in 2010 to that in 2012?
Your answer should be compact. 0.68. What is the ratio of the Insurance services (% of commercial service imports) of Gambia, The in 2010 to that in 2012?
Your response must be concise. 0.35. What is the ratio of the Insurance services (% of commercial service imports) in Turkey in 2010 to that in 2012?
Your answer should be compact. 0.84. What is the ratio of the Insurance services (% of commercial service imports) of Bosnia and Herzegovina in 2011 to that in 2012?
Your answer should be very brief. 0.78. What is the ratio of the Insurance services (% of commercial service imports) of Gambia, The in 2011 to that in 2012?
Ensure brevity in your answer.  0.49. What is the ratio of the Insurance services (% of commercial service imports) of Turkey in 2011 to that in 2012?
Your response must be concise. 1.02. What is the difference between the highest and the second highest Insurance services (% of commercial service imports) in Bosnia and Herzegovina?
Offer a terse response. 0.12. What is the difference between the highest and the second highest Insurance services (% of commercial service imports) in Gambia, The?
Offer a very short reply. 10.94. What is the difference between the highest and the second highest Insurance services (% of commercial service imports) in Turkey?
Your response must be concise. 0.57. What is the difference between the highest and the lowest Insurance services (% of commercial service imports) of Bosnia and Herzegovina?
Give a very brief answer. 6.17. What is the difference between the highest and the lowest Insurance services (% of commercial service imports) of Gambia, The?
Provide a short and direct response. 16.34. What is the difference between the highest and the lowest Insurance services (% of commercial service imports) of Turkey?
Make the answer very short. 4.25. 